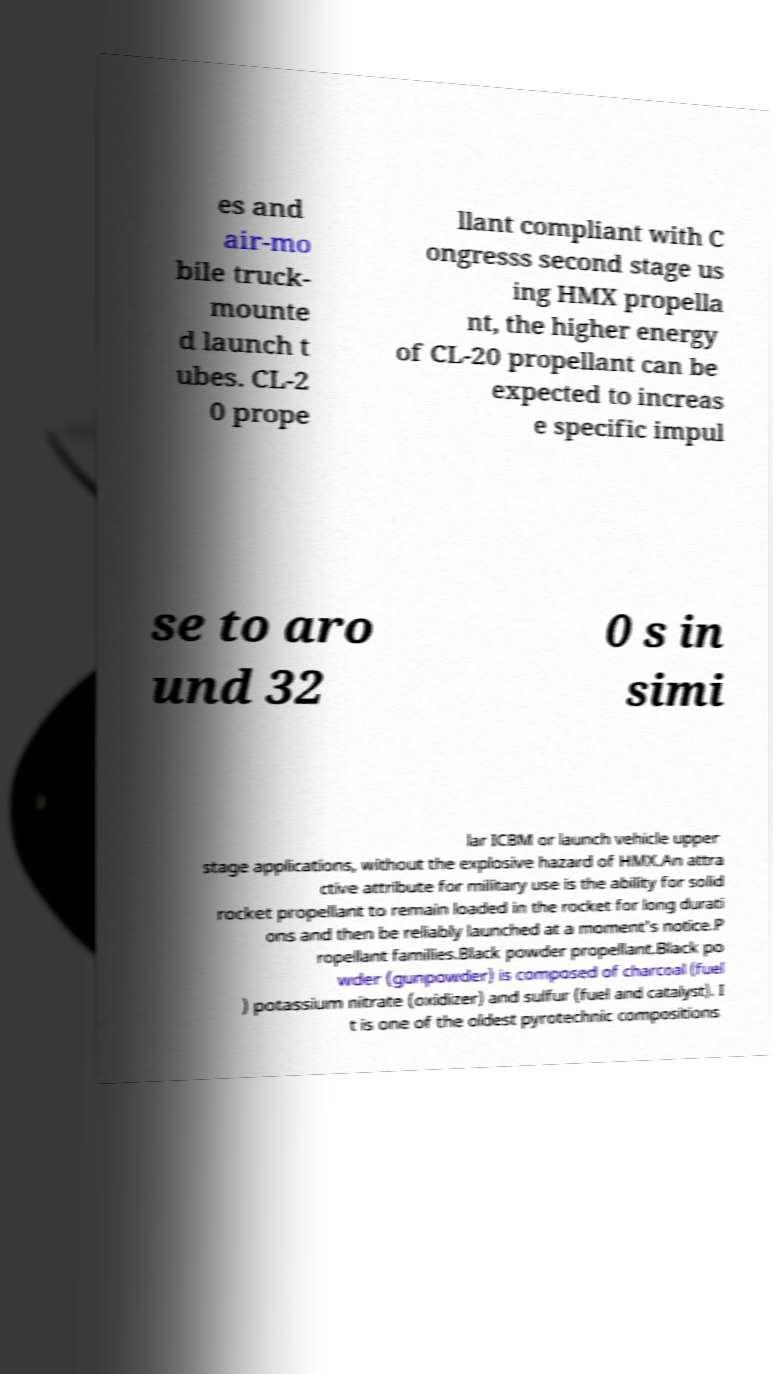There's text embedded in this image that I need extracted. Can you transcribe it verbatim? es and air-mo bile truck- mounte d launch t ubes. CL-2 0 prope llant compliant with C ongresss second stage us ing HMX propella nt, the higher energy of CL-20 propellant can be expected to increas e specific impul se to aro und 32 0 s in simi lar ICBM or launch vehicle upper stage applications, without the explosive hazard of HMX.An attra ctive attribute for military use is the ability for solid rocket propellant to remain loaded in the rocket for long durati ons and then be reliably launched at a moment's notice.P ropellant families.Black powder propellant.Black po wder (gunpowder) is composed of charcoal (fuel ) potassium nitrate (oxidizer) and sulfur (fuel and catalyst). I t is one of the oldest pyrotechnic compositions 